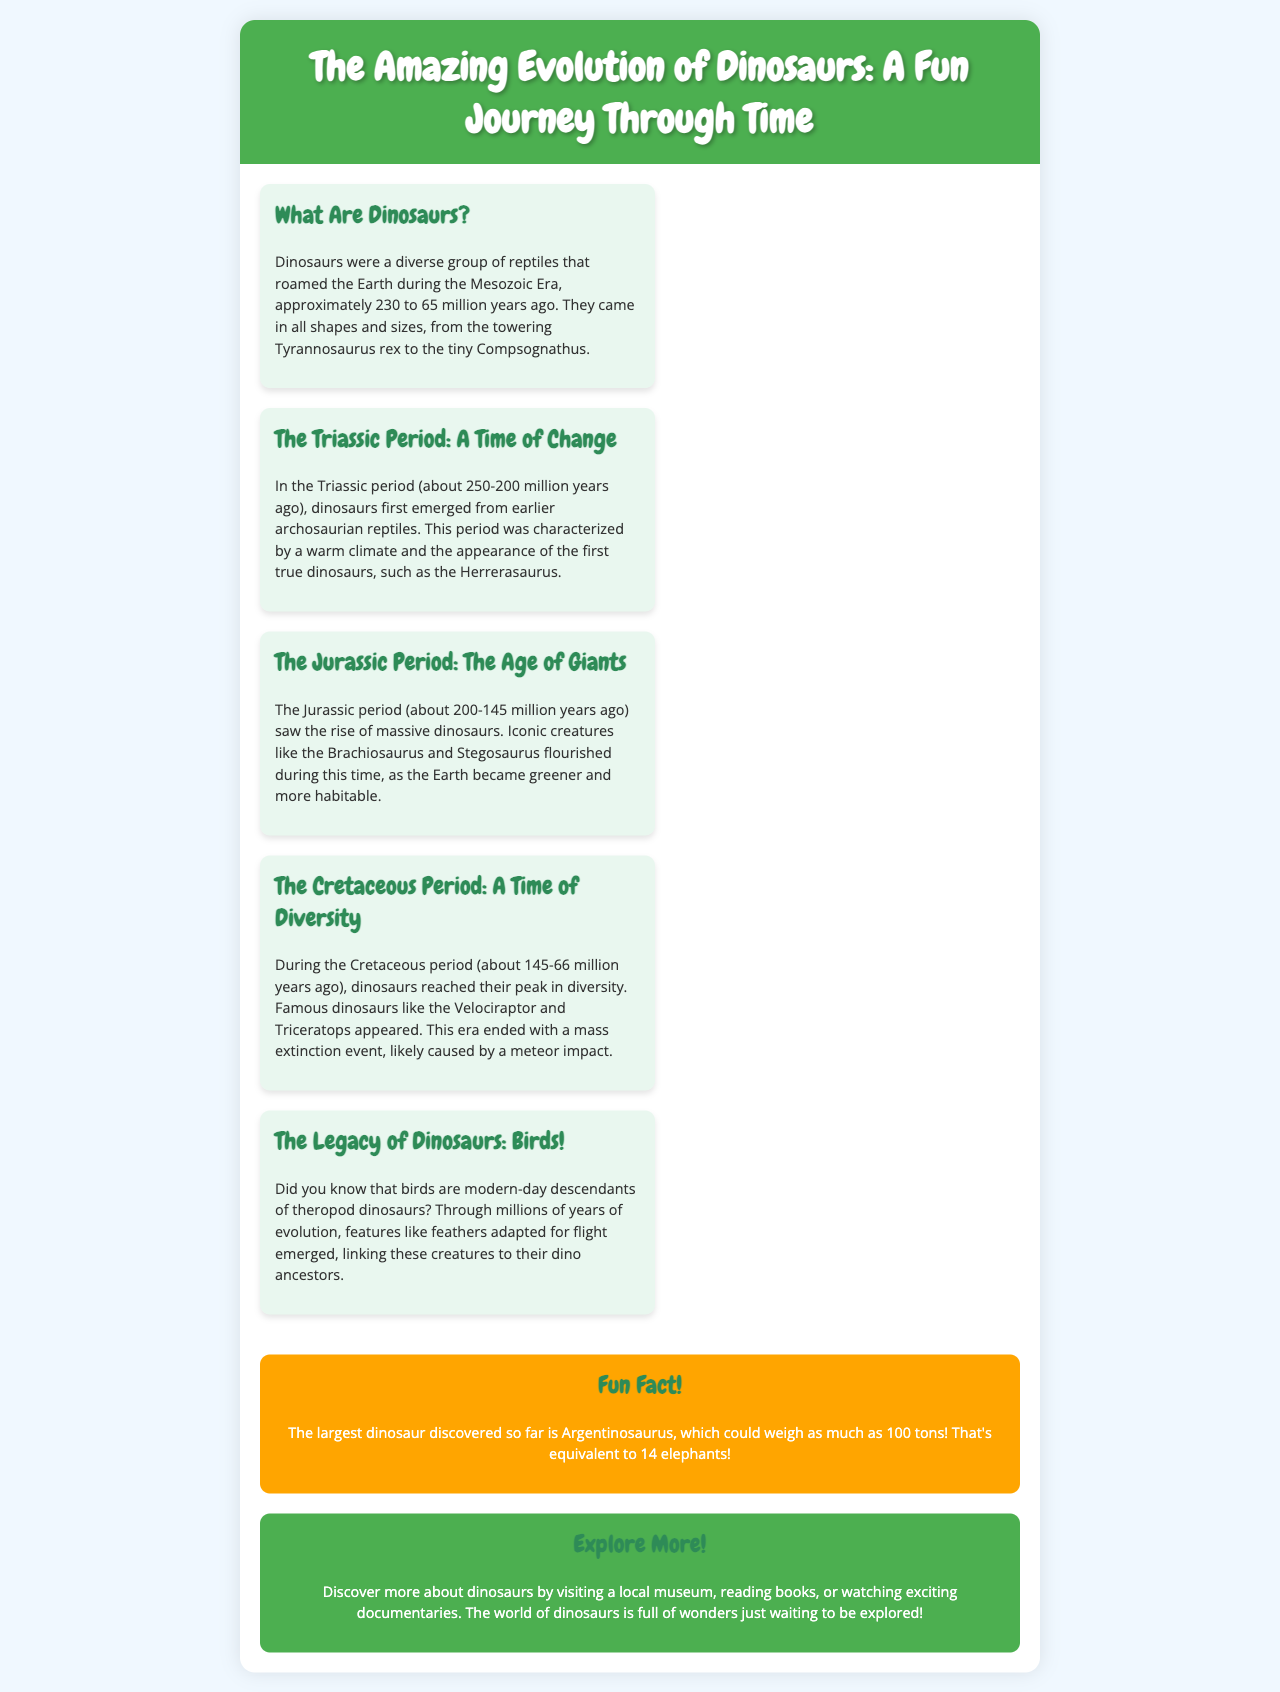What time period did dinosaurs first emerge? Dinosaurs first emerged during the Triassic period, which is specifically noted as about 250-200 million years ago.
Answer: Triassic period What is the name of the dinosaur that could weigh as much as 100 tons? The document mentions Argentinosaurus as the largest dinosaur discovered so far, which could weigh as much as 100 tons.
Answer: Argentinosaurus What characterized the Jurassic period? The Jurassic period is described as the Age of Giants, marked by the rise of massive dinosaurs, such as Brachiosaurus and Stegosaurus.
Answer: Age of Giants Which dinosaurs appeared during the Cretaceous period? The Cretaceous period saw the emergence of famous dinosaurs like the Velociraptor and Triceratops.
Answer: Velociraptor and Triceratops What are modern-day descendants of theropod dinosaurs? The document states that birds are modern-day descendants of theropod dinosaurs, linking them to their dinosaur ancestors.
Answer: Birds Why did dinosaurs reach their peak in diversity? The Cretaceous period is noted for the peak in diversity of dinosaurs, which likely relates to the warmer climate and abundant resources.
Answer: Peak in diversity What is a suggested way to learn more about dinosaurs? The document encourages visiting a local museum, reading books, or watching documentaries to discover more about dinosaurs.
Answer: Visiting a local museum How long did the Mesozoic Era span? The Mesozoic Era, during which dinosaurs roamed the Earth, is noted to have lasted from approximately 230 to 65 million years ago.
Answer: 230 to 65 million years ago 